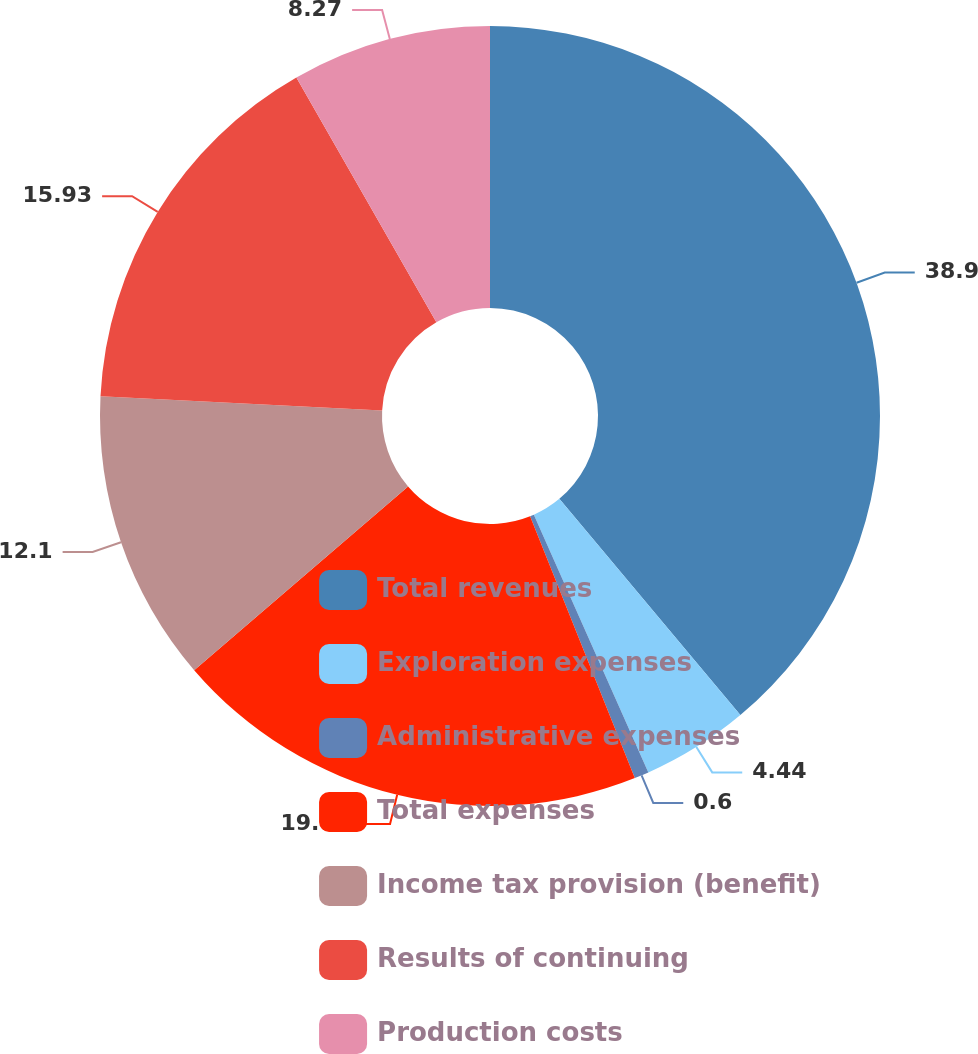Convert chart to OTSL. <chart><loc_0><loc_0><loc_500><loc_500><pie_chart><fcel>Total revenues<fcel>Exploration expenses<fcel>Administrative expenses<fcel>Total expenses<fcel>Income tax provision (benefit)<fcel>Results of continuing<fcel>Production costs<nl><fcel>38.91%<fcel>4.44%<fcel>0.6%<fcel>19.76%<fcel>12.1%<fcel>15.93%<fcel>8.27%<nl></chart> 